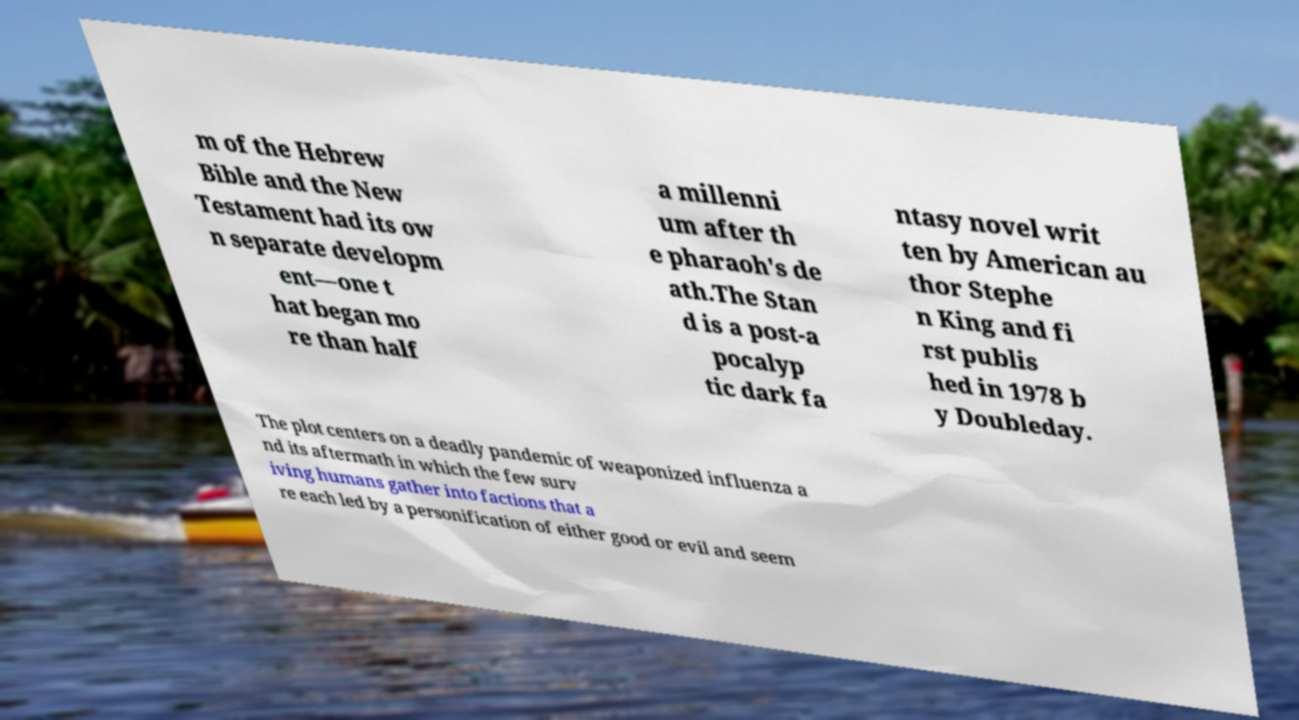For documentation purposes, I need the text within this image transcribed. Could you provide that? m of the Hebrew Bible and the New Testament had its ow n separate developm ent—one t hat began mo re than half a millenni um after th e pharaoh's de ath.The Stan d is a post-a pocalyp tic dark fa ntasy novel writ ten by American au thor Stephe n King and fi rst publis hed in 1978 b y Doubleday. The plot centers on a deadly pandemic of weaponized influenza a nd its aftermath in which the few surv iving humans gather into factions that a re each led by a personification of either good or evil and seem 